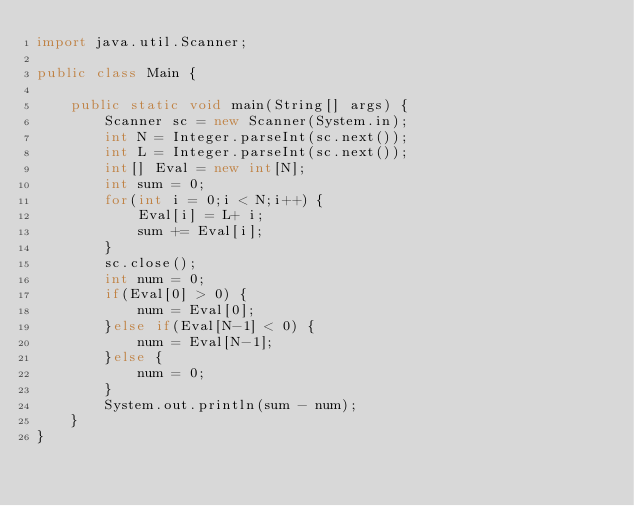Convert code to text. <code><loc_0><loc_0><loc_500><loc_500><_Java_>import java.util.Scanner;

public class Main {

	public static void main(String[] args) {
		Scanner sc = new Scanner(System.in);
		int N = Integer.parseInt(sc.next());
		int L = Integer.parseInt(sc.next());
		int[] Eval = new int[N];
		int sum = 0;
		for(int i = 0;i < N;i++) {
			Eval[i] = L+ i;
			sum += Eval[i];
		}
		sc.close();
		int num = 0;
		if(Eval[0] > 0) {
			num = Eval[0];
		}else if(Eval[N-1] < 0) {
			num = Eval[N-1];
		}else {
			num = 0;
		}
		System.out.println(sum - num);
	}
}</code> 